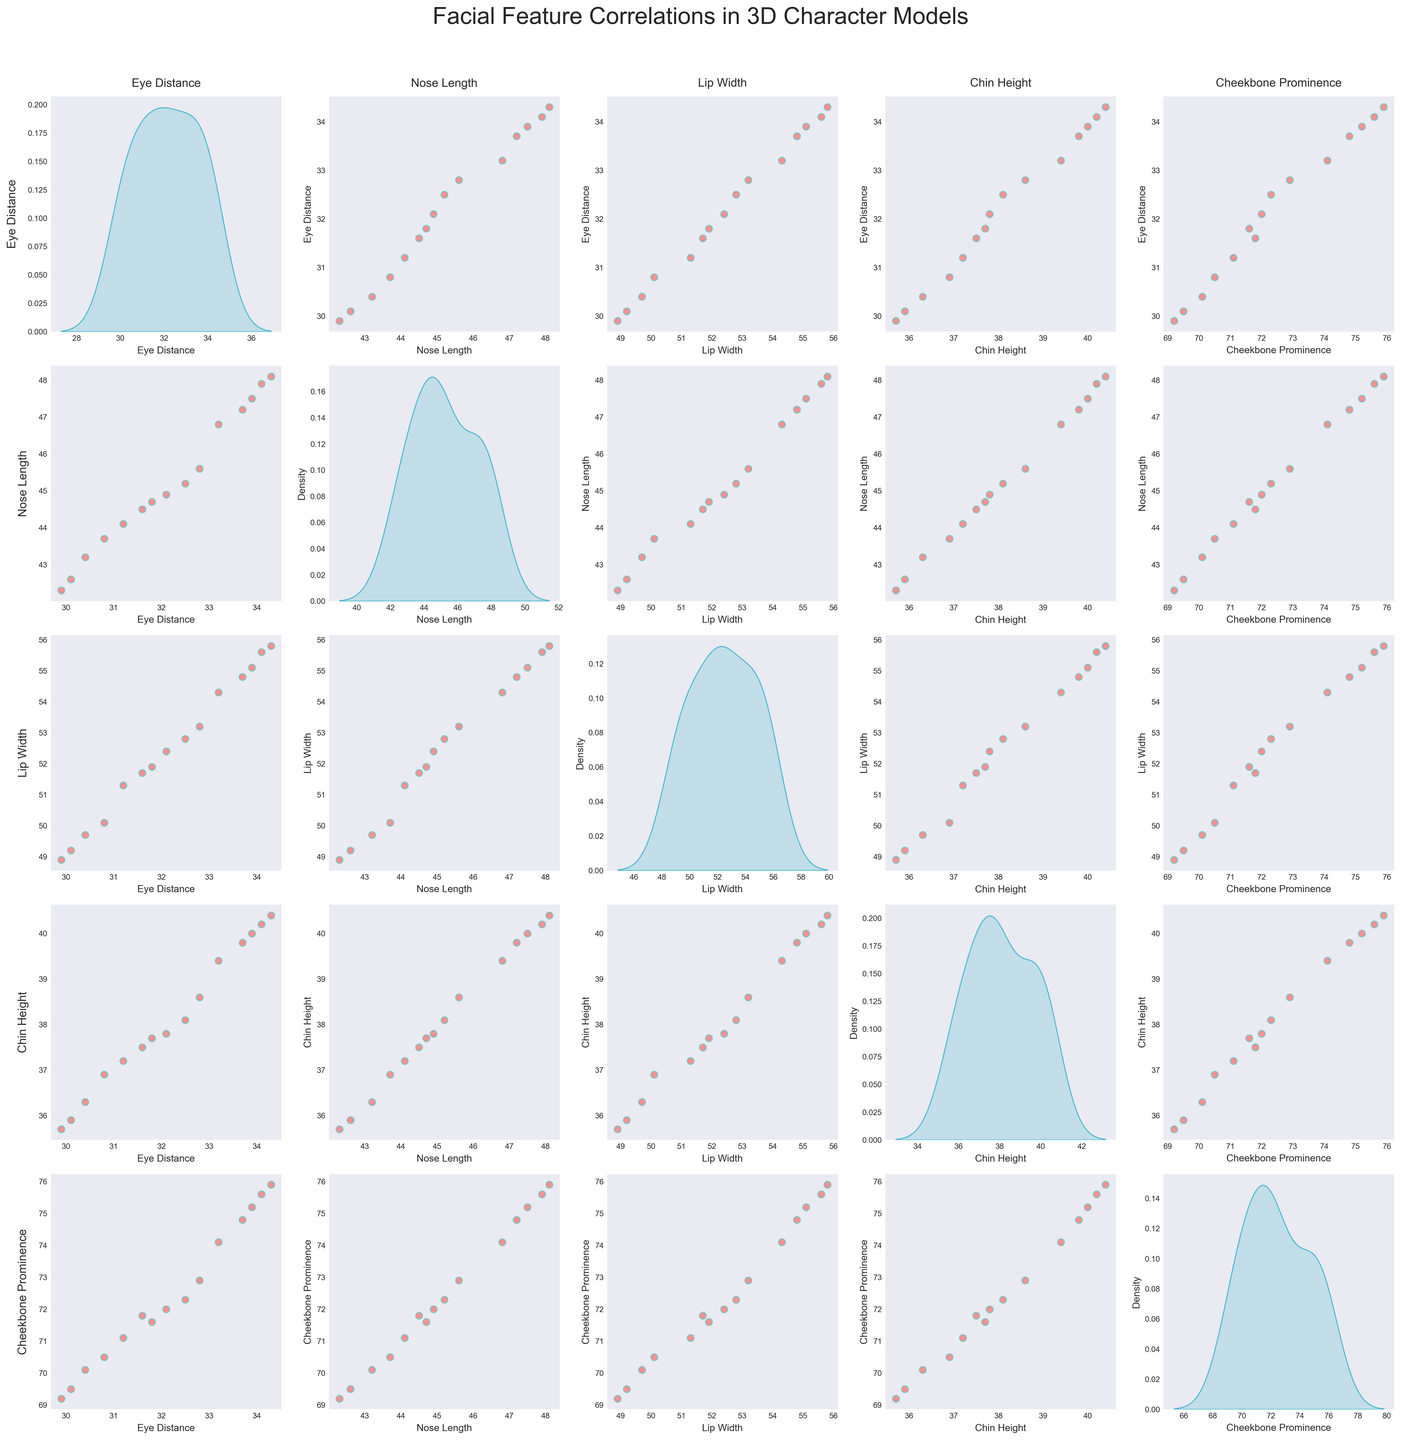What's the title of the figure? The title is placed above the plots, usually in larger, bold text. By looking at the top of the figure, you can find the title "Facial Feature Correlations in 3D Character Models".
Answer: Facial Feature Correlations in 3D Character Models Which facial feature has the highest cheekbone prominence? By referring to the diagonal KDE plots, you can find the highest peak for "Cheekbone Prominence" around the 75 value mark.
Answer: Cheekbone Prominence has the highest value around 75 How are eye distance and nose length correlated? Look at the scatter plot in the row for "Eye Distance" and column for "Nose Length". The scattered points suggest a positive correlation where an increase in eye distance corresponds to an increase in nose length.
Answer: Positively correlated Which facial feature combinations show a negative correlation? Observe the scatter plots to identify any pairs where the trend of the points slopes downward from left to right. By scanning these plots, it's evident there are no clear examples of negative correlation among the shown feature pairs.
Answer: None show a clear negative correlation What is the range of chin height values observed in the KDE plot? The KDE plot on the diagonal for "Chin Height" shows where the density is highest and the spread of values. The chin height appears to range from around 35 to 40.
Answer: 35 to 40 Comparing lip width and cheekbone prominence, which has a larger spread? By comparing the KDE plots on the diagonal for "Lip Width" and "Cheekbone Prominence", you can observe the spread. Cheekbone prominence has a wider range from about 69 to 76, whereas lip width ranges from about 49 to 56.
Answer: Cheekbone Prominence Are there any outliers in the eye distance or nose length data? Look at the scatter plots involving "Eye Distance" and "Nose Length". All points are well within the general clustering without any being drastically separated from the others, indicating no significant outliers.
Answer: No noticeable outliers Which two features seem the least correlated? By looking at scatter plots with the least linear trend, the plot for "Eye Distance" and "Cheekbone Prominence" shows very scattered points, implying low correlation.
Answer: Eye Distance and Cheekbone Prominence Do all features exhibit roughly the same number of data points? Count the points in each scatter plot and the patterns in the KDE plots on the diagonal. Each scatter plot and KDE plot has consistently the same number of points, which aligns with the given number of rows in data.
Answer: Yes 